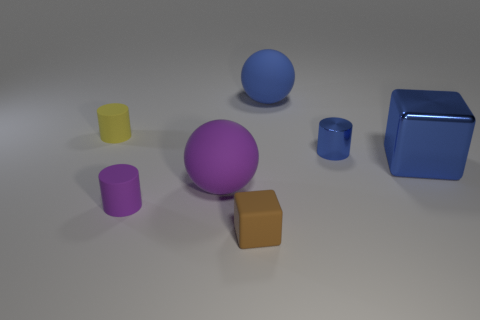How many small brown things have the same material as the tiny blue cylinder?
Ensure brevity in your answer.  0. There is a blue metal thing that is the same shape as the small brown object; what is its size?
Provide a short and direct response. Large. Are there any small objects in front of the blue shiny cube?
Offer a terse response. Yes. What is the tiny yellow thing made of?
Offer a very short reply. Rubber. There is a block to the right of the metal cylinder; is its color the same as the shiny cylinder?
Provide a succinct answer. Yes. There is another tiny rubber object that is the same shape as the tiny yellow matte thing; what is its color?
Make the answer very short. Purple. There is a large thing to the left of the large blue sphere; what is its material?
Your answer should be very brief. Rubber. The small matte cube is what color?
Keep it short and to the point. Brown. There is a cube to the right of the brown cube; is its size the same as the yellow thing?
Your answer should be very brief. No. What is the material of the ball in front of the sphere behind the small rubber object behind the blue metallic cube?
Your response must be concise. Rubber. 